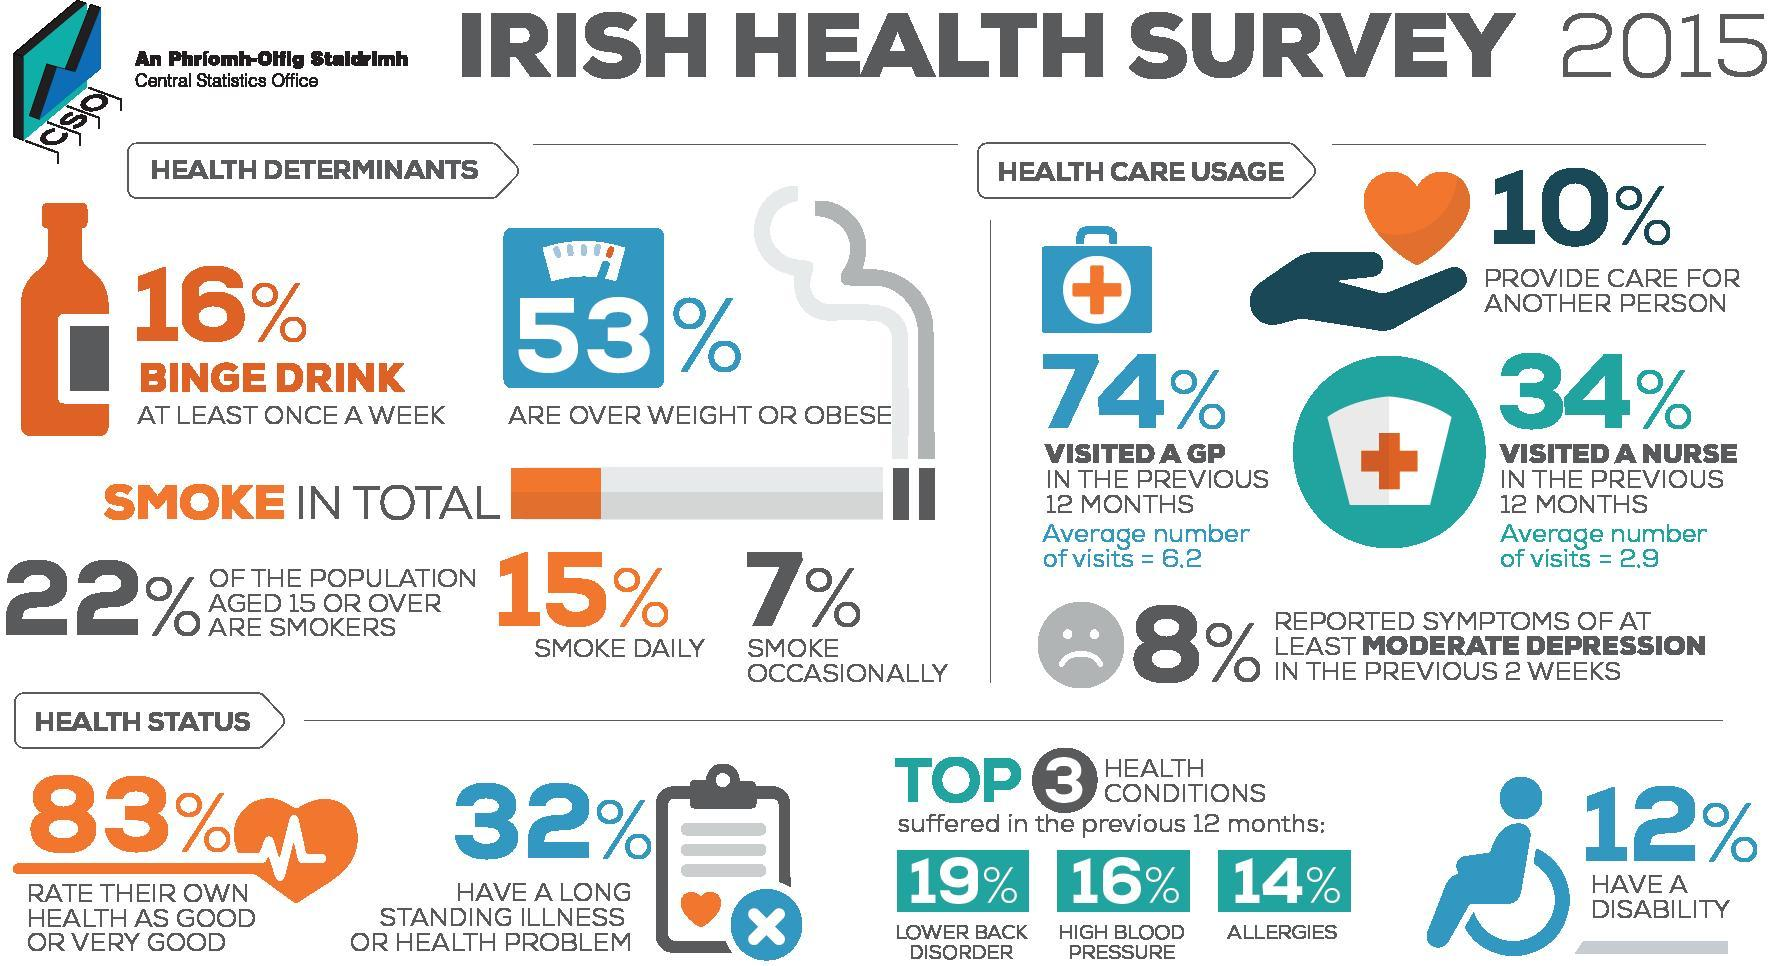What percentage of the Irish people have suffered from allergies in the previous 12 months according to the health survey in 2015?
Answer the question with a short phrase. 14% What percentage of the Irish people were suffering from lower back disorder in the previous 12 months according to the health survey in 2015? 19% What percentage of the Irish people are not obese according to the Irish health survey in 2015? 47% What is the average number of visits to a nurse by the Irish people in the previous 12 months according to the health survey in 2015? 2.9 What percentage of the Irish people do not suffer from a long standing illness according to the Irish health survey in 2015? 68% What percentage of the Irish people smoke daily according to the Irish health survey in 2015? 15% What percent of the Irish people rate their own health as good according to the Irish health survey in 2015? 83% What percentage of the Irish people have no disabilities according to the Irish health survey in 2015? 88% 